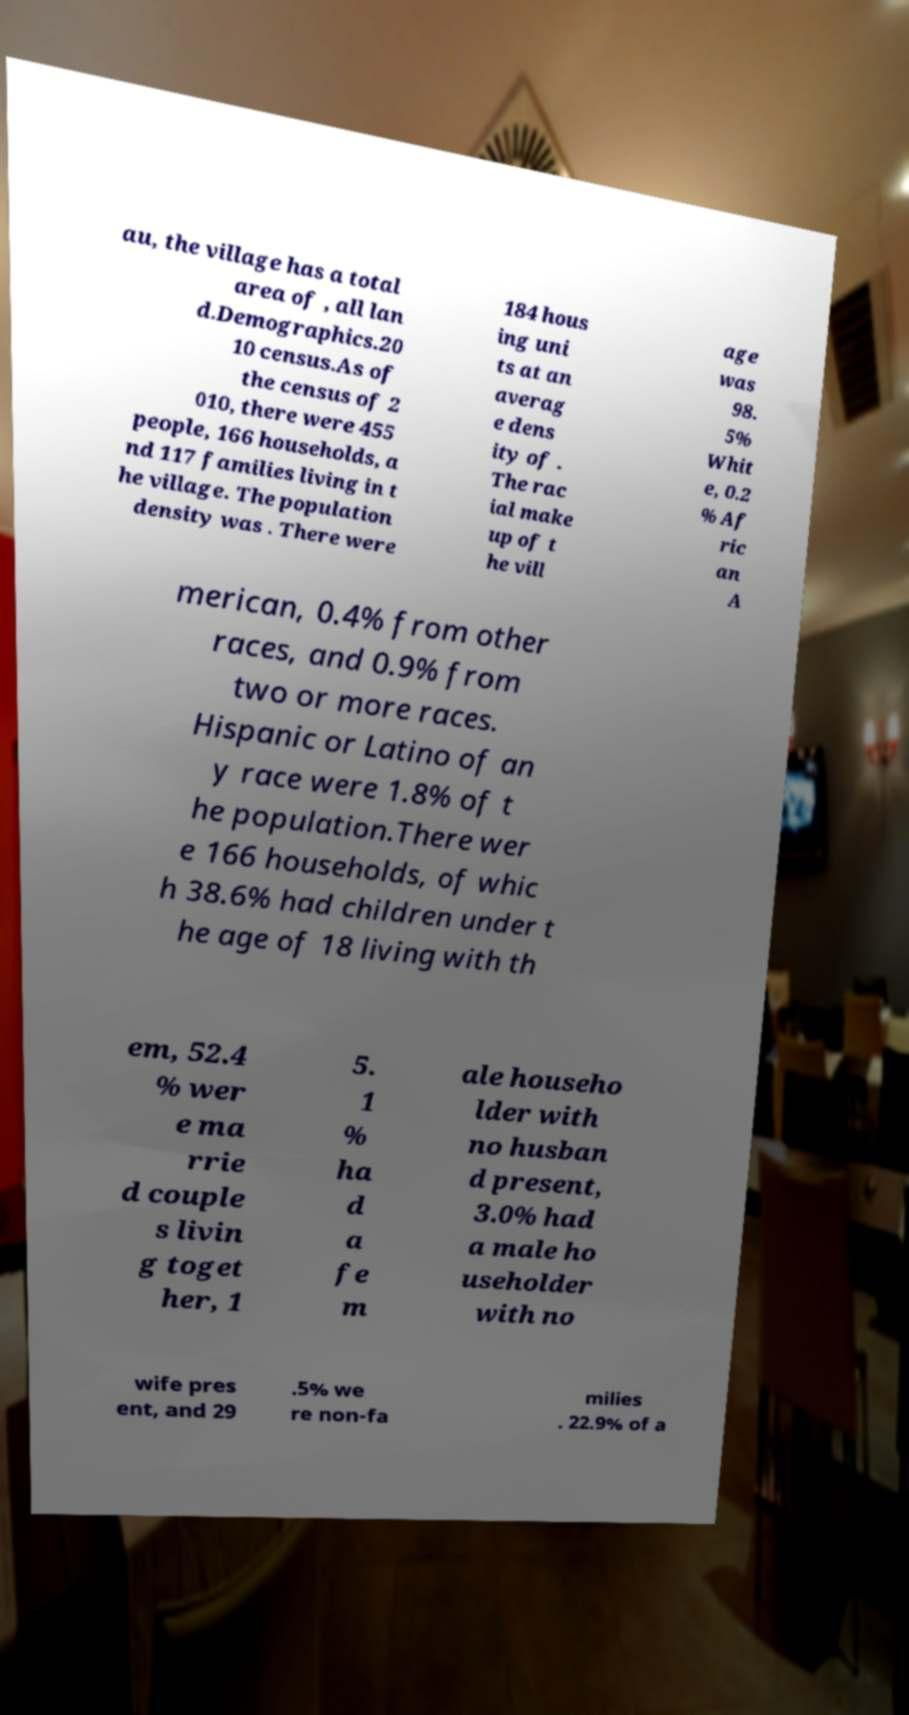Can you accurately transcribe the text from the provided image for me? au, the village has a total area of , all lan d.Demographics.20 10 census.As of the census of 2 010, there were 455 people, 166 households, a nd 117 families living in t he village. The population density was . There were 184 hous ing uni ts at an averag e dens ity of . The rac ial make up of t he vill age was 98. 5% Whit e, 0.2 % Af ric an A merican, 0.4% from other races, and 0.9% from two or more races. Hispanic or Latino of an y race were 1.8% of t he population.There wer e 166 households, of whic h 38.6% had children under t he age of 18 living with th em, 52.4 % wer e ma rrie d couple s livin g toget her, 1 5. 1 % ha d a fe m ale househo lder with no husban d present, 3.0% had a male ho useholder with no wife pres ent, and 29 .5% we re non-fa milies . 22.9% of a 